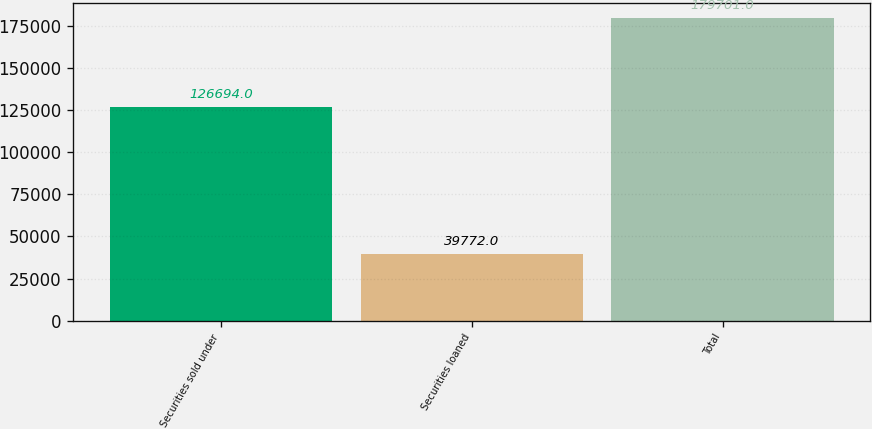<chart> <loc_0><loc_0><loc_500><loc_500><bar_chart><fcel>Securities sold under<fcel>Securities loaned<fcel>Total<nl><fcel>126694<fcel>39772<fcel>179701<nl></chart> 